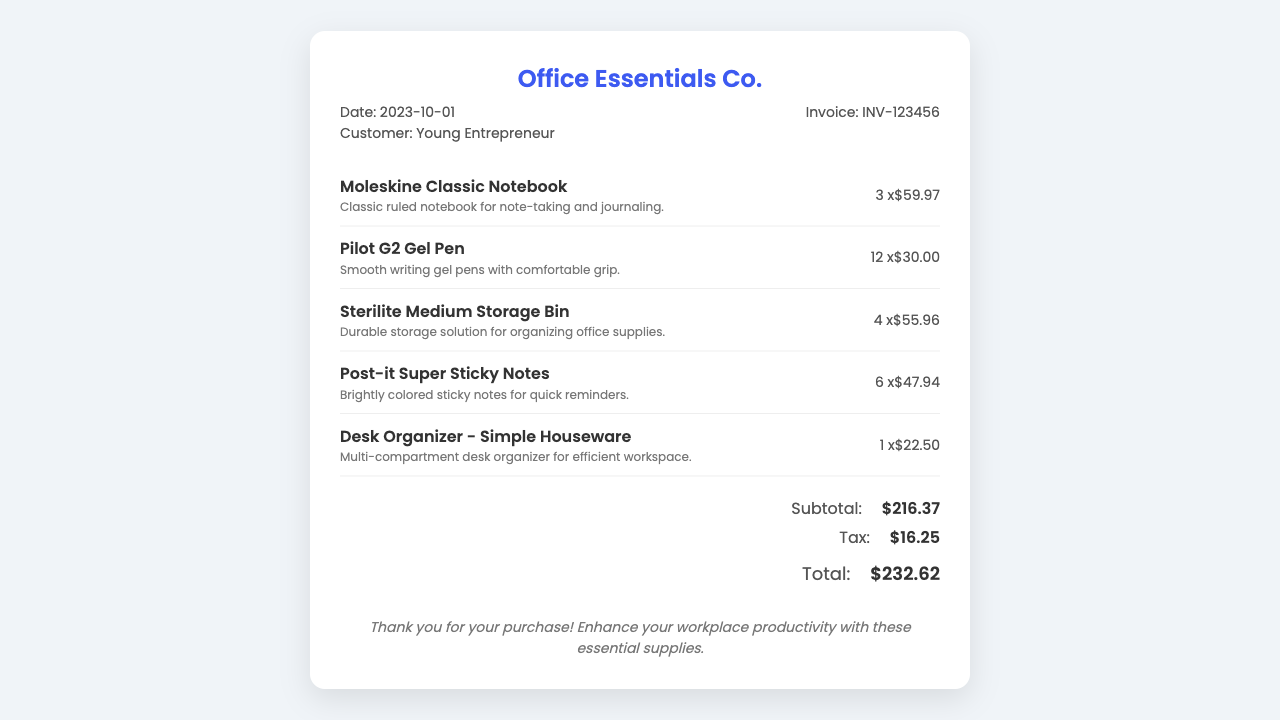What is the customer name? The receipt specifies the customer’s name, which is listed as "Young Entrepreneur."
Answer: Young Entrepreneur What is the date of purchase? The date of purchase can be found in the receipt details, listed directly under the company name as "2023-10-01."
Answer: 2023-10-01 How many Moleskine Classic Notebooks were purchased? The quantity of Moleskine Classic Notebooks purchased is stated within the item section as "3 x."
Answer: 3 What is the total amount including tax? The grand total, listed at the bottom of the receipt, includes the subtotal and tax, which together make up "232.62."
Answer: 232.62 What is the price of the Desk Organizer? The price for the Desk Organizer is indicated with the item, specifically as "$22.50."
Answer: $22.50 What is the subtotal before tax? The subtotal amount appears prominently in the totals section, noted as "$216.37."
Answer: $216.37 What type of document is this? This document serves as a receipt, evidenced by the clear header stating "Office Essentials Co. Receipt."
Answer: Receipt What item has the highest quantity purchased? The item with the highest quantity indicated is the "Pilot G2 Gel Pen," purchased in "12 x" quantity.
Answer: Pilot G2 Gel Pen How many items are listed on the receipt? The number of items can be counted within the items section where there are five distinct entries.
Answer: 5 